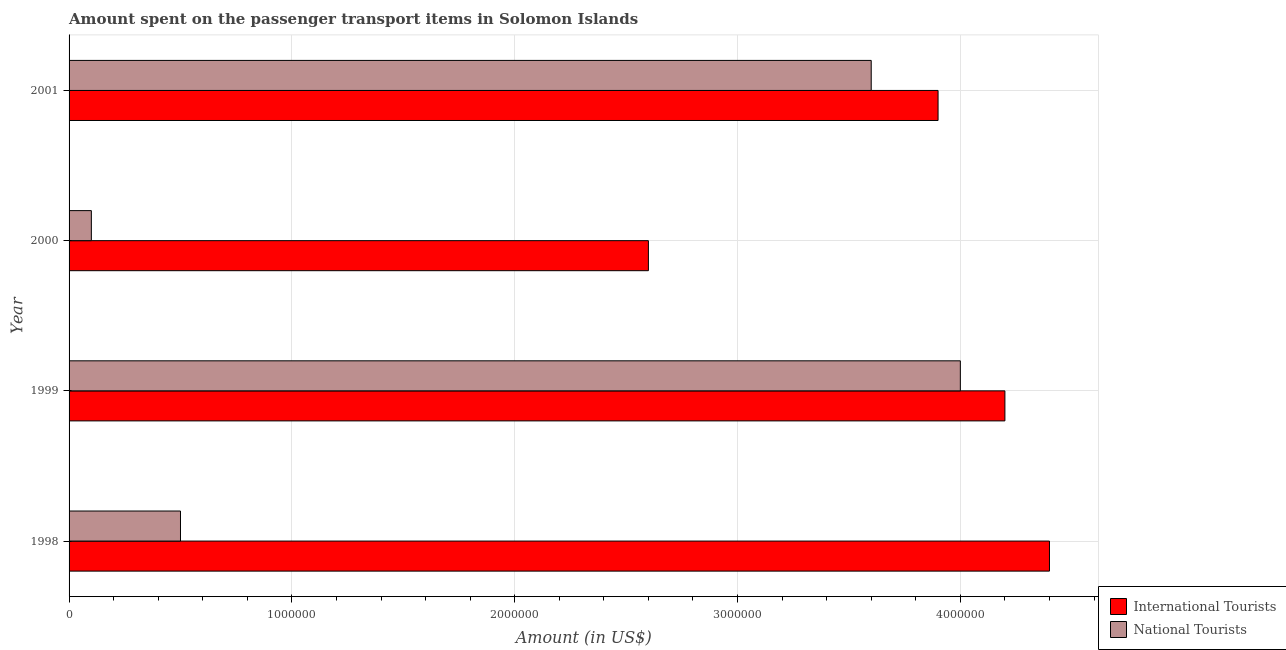Are the number of bars on each tick of the Y-axis equal?
Keep it short and to the point. Yes. What is the label of the 1st group of bars from the top?
Provide a succinct answer. 2001. What is the amount spent on transport items of national tourists in 1999?
Make the answer very short. 4.00e+06. Across all years, what is the maximum amount spent on transport items of international tourists?
Give a very brief answer. 4.40e+06. Across all years, what is the minimum amount spent on transport items of international tourists?
Offer a terse response. 2.60e+06. In which year was the amount spent on transport items of international tourists minimum?
Your answer should be very brief. 2000. What is the total amount spent on transport items of national tourists in the graph?
Give a very brief answer. 8.20e+06. What is the difference between the amount spent on transport items of national tourists in 1998 and that in 1999?
Make the answer very short. -3.50e+06. What is the difference between the amount spent on transport items of national tourists in 1999 and the amount spent on transport items of international tourists in 1998?
Make the answer very short. -4.00e+05. What is the average amount spent on transport items of national tourists per year?
Your answer should be very brief. 2.05e+06. In the year 1998, what is the difference between the amount spent on transport items of national tourists and amount spent on transport items of international tourists?
Keep it short and to the point. -3.90e+06. What is the ratio of the amount spent on transport items of national tourists in 1998 to that in 1999?
Make the answer very short. 0.12. Is the difference between the amount spent on transport items of national tourists in 1998 and 2000 greater than the difference between the amount spent on transport items of international tourists in 1998 and 2000?
Your answer should be compact. No. What is the difference between the highest and the second highest amount spent on transport items of national tourists?
Ensure brevity in your answer.  4.00e+05. What is the difference between the highest and the lowest amount spent on transport items of national tourists?
Your answer should be compact. 3.90e+06. Is the sum of the amount spent on transport items of national tourists in 1998 and 2000 greater than the maximum amount spent on transport items of international tourists across all years?
Give a very brief answer. No. What does the 1st bar from the top in 1999 represents?
Your answer should be compact. National Tourists. What does the 2nd bar from the bottom in 2001 represents?
Your answer should be compact. National Tourists. Are all the bars in the graph horizontal?
Ensure brevity in your answer.  Yes. Does the graph contain any zero values?
Ensure brevity in your answer.  No. Does the graph contain grids?
Provide a succinct answer. Yes. Where does the legend appear in the graph?
Provide a short and direct response. Bottom right. How many legend labels are there?
Your response must be concise. 2. What is the title of the graph?
Offer a terse response. Amount spent on the passenger transport items in Solomon Islands. What is the label or title of the Y-axis?
Your answer should be compact. Year. What is the Amount (in US$) of International Tourists in 1998?
Give a very brief answer. 4.40e+06. What is the Amount (in US$) in National Tourists in 1998?
Keep it short and to the point. 5.00e+05. What is the Amount (in US$) of International Tourists in 1999?
Keep it short and to the point. 4.20e+06. What is the Amount (in US$) in National Tourists in 1999?
Provide a succinct answer. 4.00e+06. What is the Amount (in US$) of International Tourists in 2000?
Your answer should be compact. 2.60e+06. What is the Amount (in US$) in National Tourists in 2000?
Ensure brevity in your answer.  1.00e+05. What is the Amount (in US$) in International Tourists in 2001?
Your answer should be compact. 3.90e+06. What is the Amount (in US$) in National Tourists in 2001?
Provide a succinct answer. 3.60e+06. Across all years, what is the maximum Amount (in US$) of International Tourists?
Offer a terse response. 4.40e+06. Across all years, what is the minimum Amount (in US$) of International Tourists?
Make the answer very short. 2.60e+06. What is the total Amount (in US$) in International Tourists in the graph?
Make the answer very short. 1.51e+07. What is the total Amount (in US$) of National Tourists in the graph?
Offer a very short reply. 8.20e+06. What is the difference between the Amount (in US$) of International Tourists in 1998 and that in 1999?
Your answer should be very brief. 2.00e+05. What is the difference between the Amount (in US$) in National Tourists in 1998 and that in 1999?
Your answer should be compact. -3.50e+06. What is the difference between the Amount (in US$) of International Tourists in 1998 and that in 2000?
Offer a terse response. 1.80e+06. What is the difference between the Amount (in US$) in National Tourists in 1998 and that in 2000?
Make the answer very short. 4.00e+05. What is the difference between the Amount (in US$) in International Tourists in 1998 and that in 2001?
Ensure brevity in your answer.  5.00e+05. What is the difference between the Amount (in US$) in National Tourists in 1998 and that in 2001?
Ensure brevity in your answer.  -3.10e+06. What is the difference between the Amount (in US$) of International Tourists in 1999 and that in 2000?
Ensure brevity in your answer.  1.60e+06. What is the difference between the Amount (in US$) of National Tourists in 1999 and that in 2000?
Provide a short and direct response. 3.90e+06. What is the difference between the Amount (in US$) of International Tourists in 1999 and that in 2001?
Provide a succinct answer. 3.00e+05. What is the difference between the Amount (in US$) in National Tourists in 1999 and that in 2001?
Provide a succinct answer. 4.00e+05. What is the difference between the Amount (in US$) of International Tourists in 2000 and that in 2001?
Your response must be concise. -1.30e+06. What is the difference between the Amount (in US$) in National Tourists in 2000 and that in 2001?
Provide a short and direct response. -3.50e+06. What is the difference between the Amount (in US$) of International Tourists in 1998 and the Amount (in US$) of National Tourists in 2000?
Your answer should be very brief. 4.30e+06. What is the difference between the Amount (in US$) of International Tourists in 1998 and the Amount (in US$) of National Tourists in 2001?
Your response must be concise. 8.00e+05. What is the difference between the Amount (in US$) of International Tourists in 1999 and the Amount (in US$) of National Tourists in 2000?
Your answer should be very brief. 4.10e+06. What is the difference between the Amount (in US$) in International Tourists in 1999 and the Amount (in US$) in National Tourists in 2001?
Provide a succinct answer. 6.00e+05. What is the difference between the Amount (in US$) in International Tourists in 2000 and the Amount (in US$) in National Tourists in 2001?
Give a very brief answer. -1.00e+06. What is the average Amount (in US$) in International Tourists per year?
Your answer should be very brief. 3.78e+06. What is the average Amount (in US$) of National Tourists per year?
Your answer should be very brief. 2.05e+06. In the year 1998, what is the difference between the Amount (in US$) in International Tourists and Amount (in US$) in National Tourists?
Keep it short and to the point. 3.90e+06. In the year 2000, what is the difference between the Amount (in US$) of International Tourists and Amount (in US$) of National Tourists?
Offer a terse response. 2.50e+06. In the year 2001, what is the difference between the Amount (in US$) of International Tourists and Amount (in US$) of National Tourists?
Keep it short and to the point. 3.00e+05. What is the ratio of the Amount (in US$) in International Tourists in 1998 to that in 1999?
Provide a short and direct response. 1.05. What is the ratio of the Amount (in US$) in International Tourists in 1998 to that in 2000?
Offer a terse response. 1.69. What is the ratio of the Amount (in US$) of National Tourists in 1998 to that in 2000?
Give a very brief answer. 5. What is the ratio of the Amount (in US$) in International Tourists in 1998 to that in 2001?
Your answer should be compact. 1.13. What is the ratio of the Amount (in US$) in National Tourists in 1998 to that in 2001?
Provide a succinct answer. 0.14. What is the ratio of the Amount (in US$) of International Tourists in 1999 to that in 2000?
Your response must be concise. 1.62. What is the ratio of the Amount (in US$) of International Tourists in 1999 to that in 2001?
Offer a terse response. 1.08. What is the ratio of the Amount (in US$) in International Tourists in 2000 to that in 2001?
Your response must be concise. 0.67. What is the ratio of the Amount (in US$) in National Tourists in 2000 to that in 2001?
Your answer should be very brief. 0.03. What is the difference between the highest and the second highest Amount (in US$) of National Tourists?
Keep it short and to the point. 4.00e+05. What is the difference between the highest and the lowest Amount (in US$) of International Tourists?
Ensure brevity in your answer.  1.80e+06. What is the difference between the highest and the lowest Amount (in US$) in National Tourists?
Your answer should be compact. 3.90e+06. 